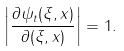Convert formula to latex. <formula><loc_0><loc_0><loc_500><loc_500>\left | \frac { \partial \psi _ { t } ( \xi , x ) } { \partial ( \xi , x ) } \right | = 1 .</formula> 